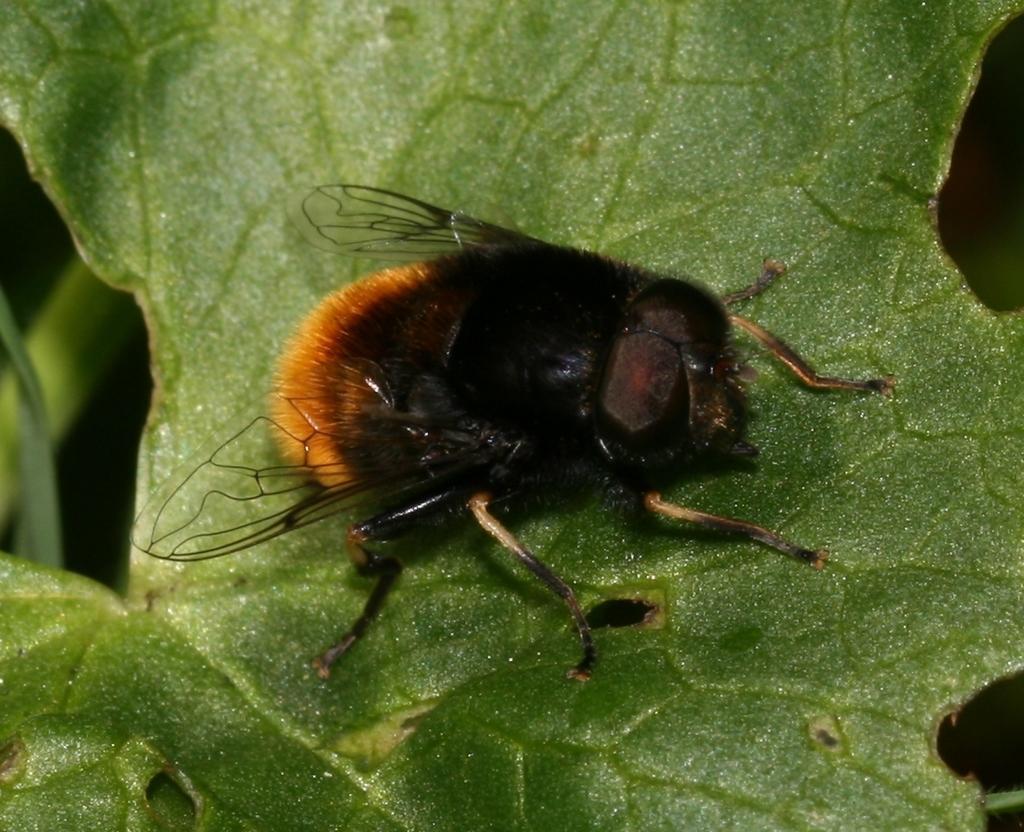Can you describe this image briefly? In this picture there is a fly on the leaf. On the left I can see the plant branch. In the back I can see the darkness. 